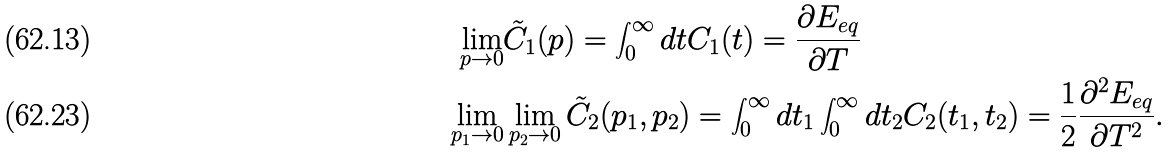Convert formula to latex. <formula><loc_0><loc_0><loc_500><loc_500>\lim _ { p \to 0 } & \tilde { C } _ { 1 } ( p ) = \int _ { 0 } ^ { \infty } d t C _ { 1 } ( t ) = \frac { \partial E _ { e q } } { \partial T } \\ \lim _ { p _ { 1 } \to 0 } & \lim _ { p _ { 2 } \to 0 } \tilde { C } _ { 2 } ( p _ { 1 } , p _ { 2 } ) = \int _ { 0 } ^ { \infty } d t _ { 1 } \int _ { 0 } ^ { \infty } d t _ { 2 } C _ { 2 } ( t _ { 1 } , t _ { 2 } ) = \frac { 1 } { 2 } \frac { \partial ^ { 2 } E _ { e q } } { \partial T ^ { 2 } } .</formula> 